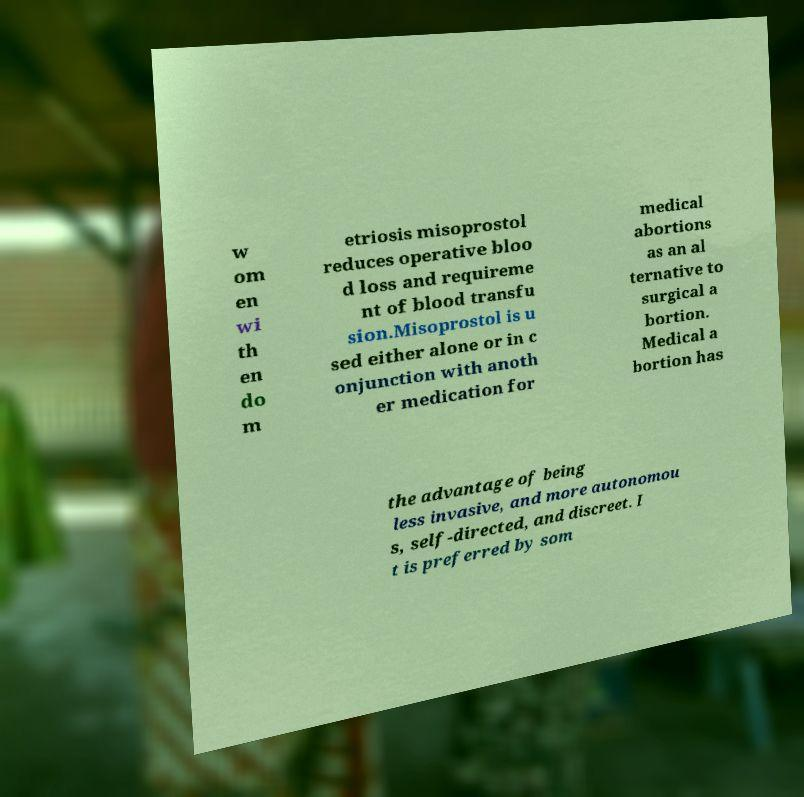Please identify and transcribe the text found in this image. w om en wi th en do m etriosis misoprostol reduces operative bloo d loss and requireme nt of blood transfu sion.Misoprostol is u sed either alone or in c onjunction with anoth er medication for medical abortions as an al ternative to surgical a bortion. Medical a bortion has the advantage of being less invasive, and more autonomou s, self-directed, and discreet. I t is preferred by som 